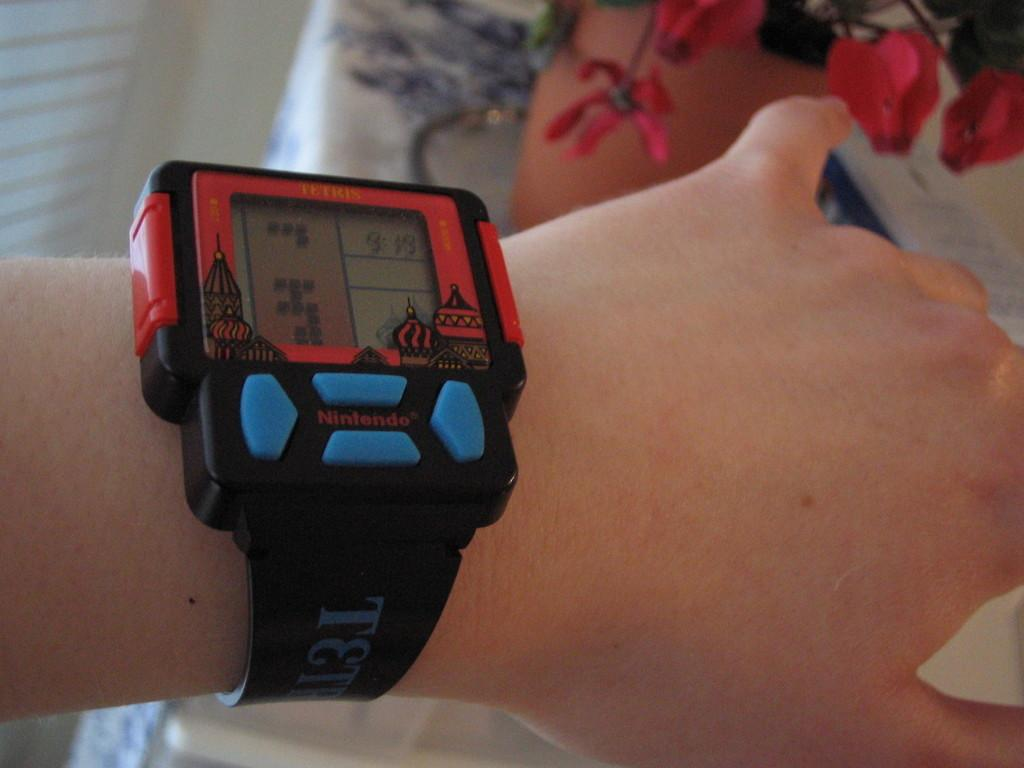Provide a one-sentence caption for the provided image. a watch with the letter T on the side of it. 